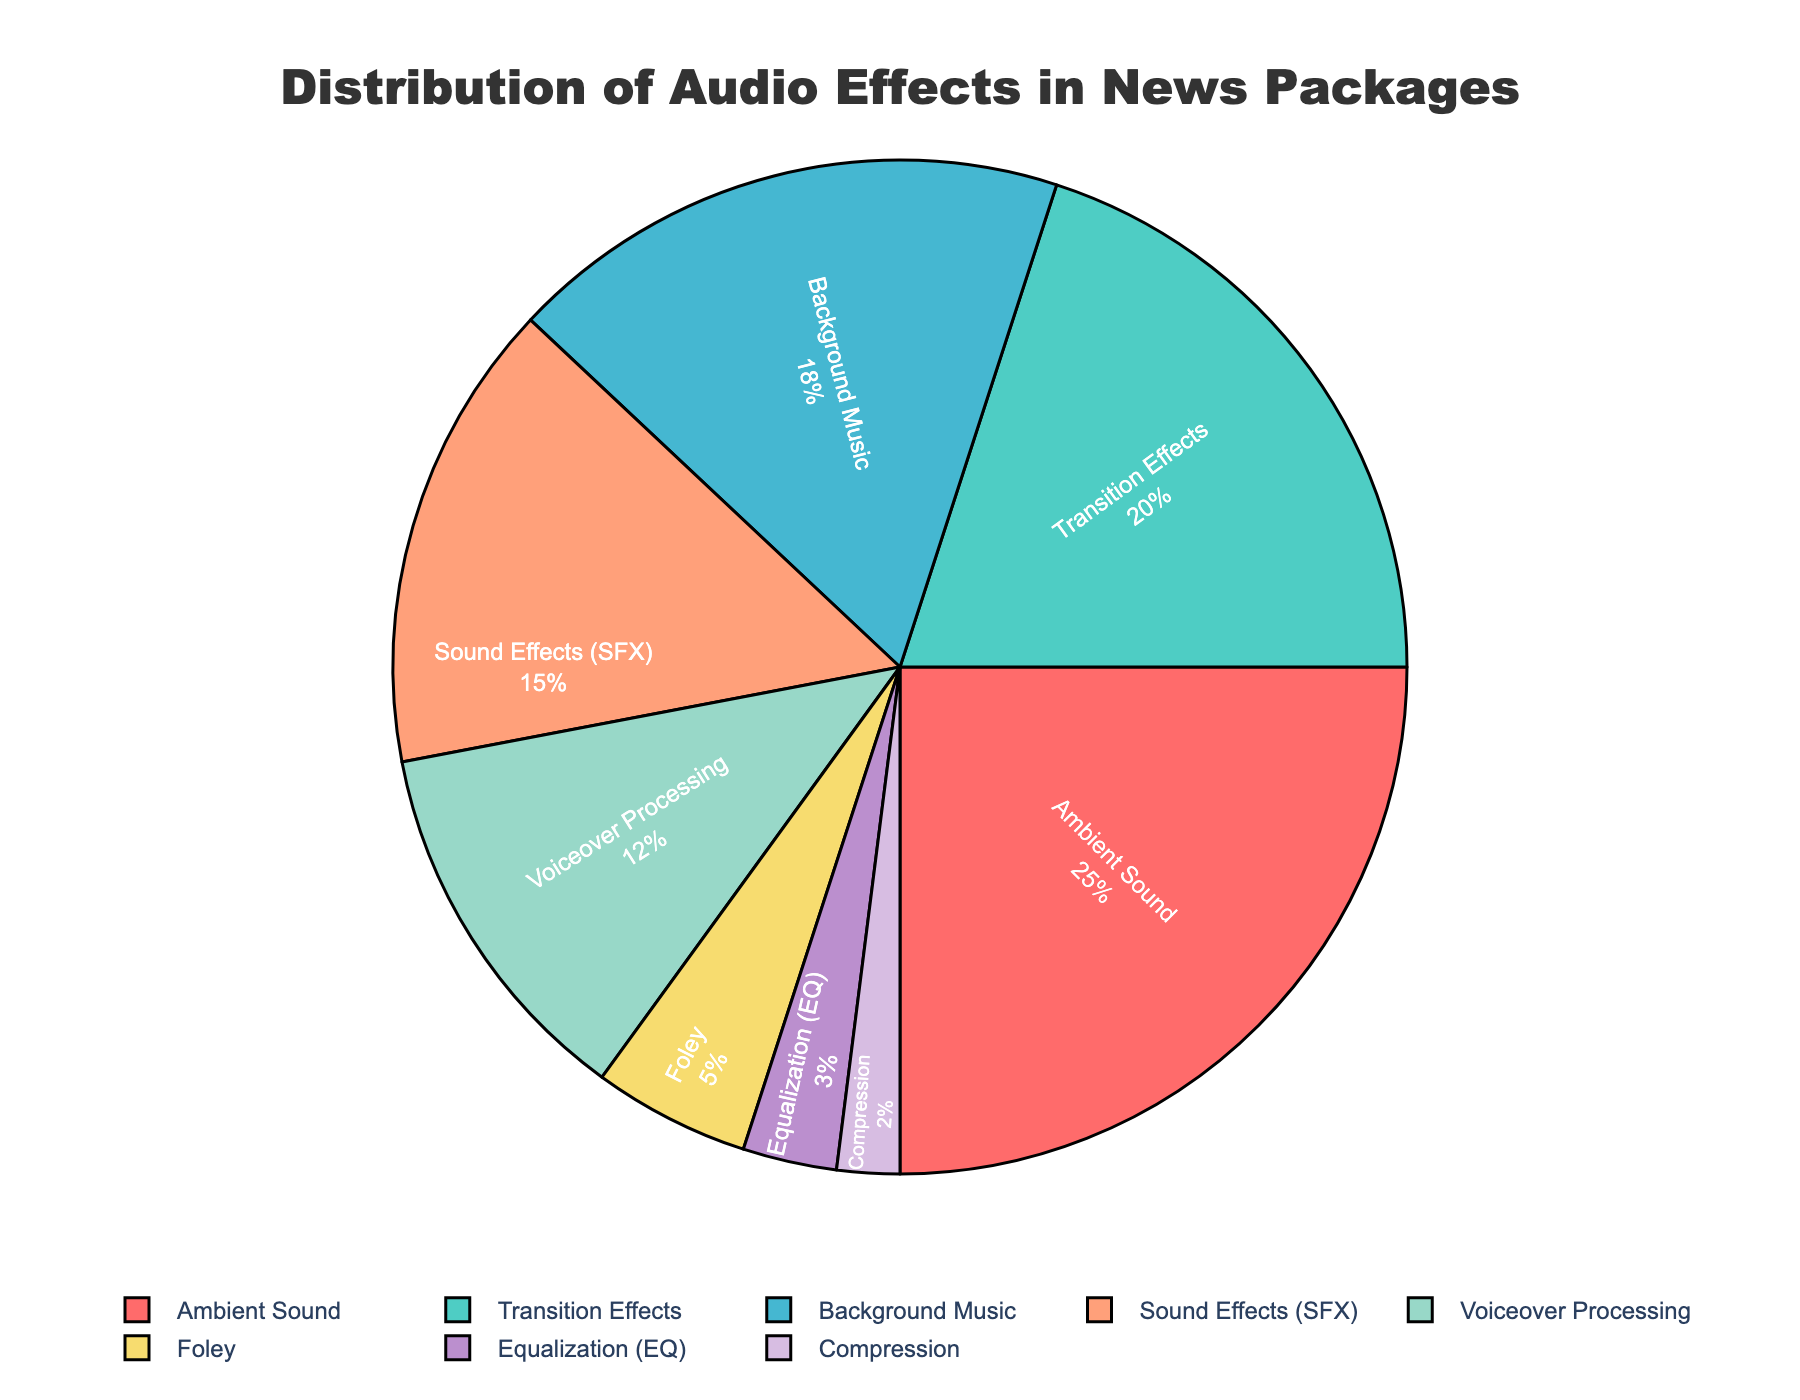Which category has the highest percentage of use? By looking at the pie chart, identify the category with the largest slice, which is labeled with both its name and percentage. The category with the highest percentage slice is "Ambient Sound" at 25%.
Answer: Ambient Sound Which two categories combined make up less than 10% of the total usage? Identify the categories from the pie chart with percentages that, when summed, are less than 10%. "Equalization (EQ)" and "Compression" have percentages of 3% and 2%, respectively, which sum to 5%.
Answer: Equalization (EQ) and Compression How much more is the percentage for Transition Effects compared to Foley? Find the percentages for both categories from the pie chart. Transition Effects is 20% and Foley is 5%. Subtract the smaller percentage from the larger one: 20% - 5% = 15%.
Answer: 15% Which color represents Background Music in the pie chart? Identify the color associated with the "Background Music" label in the pie chart. Background Music is represented by a green slice.
Answer: Green What are the combined percentages for Sound Effects (SFX) and Voiceover Processing? Look at the pie chart to find the percentages for "Sound Effects (SFX)" and "Voiceover Processing." Sum them up: 15% + 12% = 27%.
Answer: 27% Is the percentage of Ambient Sound greater than the combined percentage of Equalization (EQ) and Compression? Compare the percentage of "Ambient Sound" (25%) with the combined percentages of "Equalization (EQ)" (3%) and "Compression" (2%). Calculate the sum of Equalization and Compression: 3% + 2% = 5%. Since 25% is greater than 5%, the statement is true.
Answer: Yes Which category has the smallest representation in the pie chart? Identify the category with the smallest percentage by looking at the pie chart. "Compression" has the smallest slice at 2%.
Answer: Compression What percentage less is Voiceover Processing compared to Background Music? Find the percentages for both "Voiceover Processing" (12%) and "Background Music" (18%). Subtract the smaller percentage from the larger one: 18% - 12% = 6%.
Answer: 6% What is the total percentage represented by Transition Effects, Background Music, and Sound Effects (SFX)? Find the percentages for "Transition Effects" (20%), "Background Music" (18%), and "Sound Effects (SFX)" (15%). Sum them up: 20% + 18% + 15% = 53%.
Answer: 53% If we group Foley and Equalization (EQ) into a new category called "Manual Adjustments," what percentage does it represent? Combine "Foley" (5%) and "Equalization (EQ)" (3%) into the new category "Manual Adjustments" and sum their percentages: 5% + 3% = 8%.
Answer: 8% 